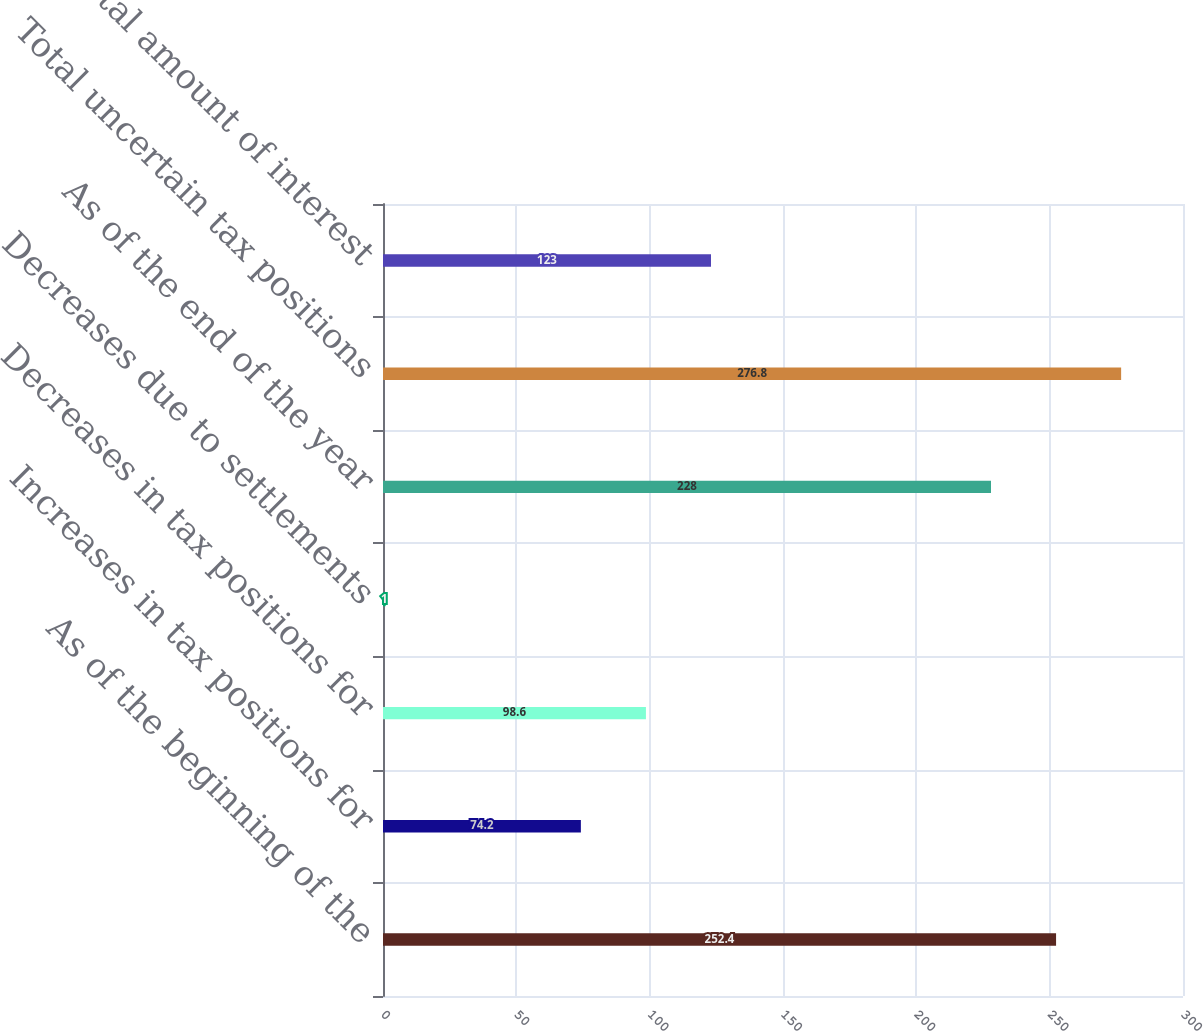Convert chart. <chart><loc_0><loc_0><loc_500><loc_500><bar_chart><fcel>As of the beginning of the<fcel>Increases in tax positions for<fcel>Decreases in tax positions for<fcel>Decreases due to settlements<fcel>As of the end of the year<fcel>Total uncertain tax positions<fcel>Total amount of interest<nl><fcel>252.4<fcel>74.2<fcel>98.6<fcel>1<fcel>228<fcel>276.8<fcel>123<nl></chart> 